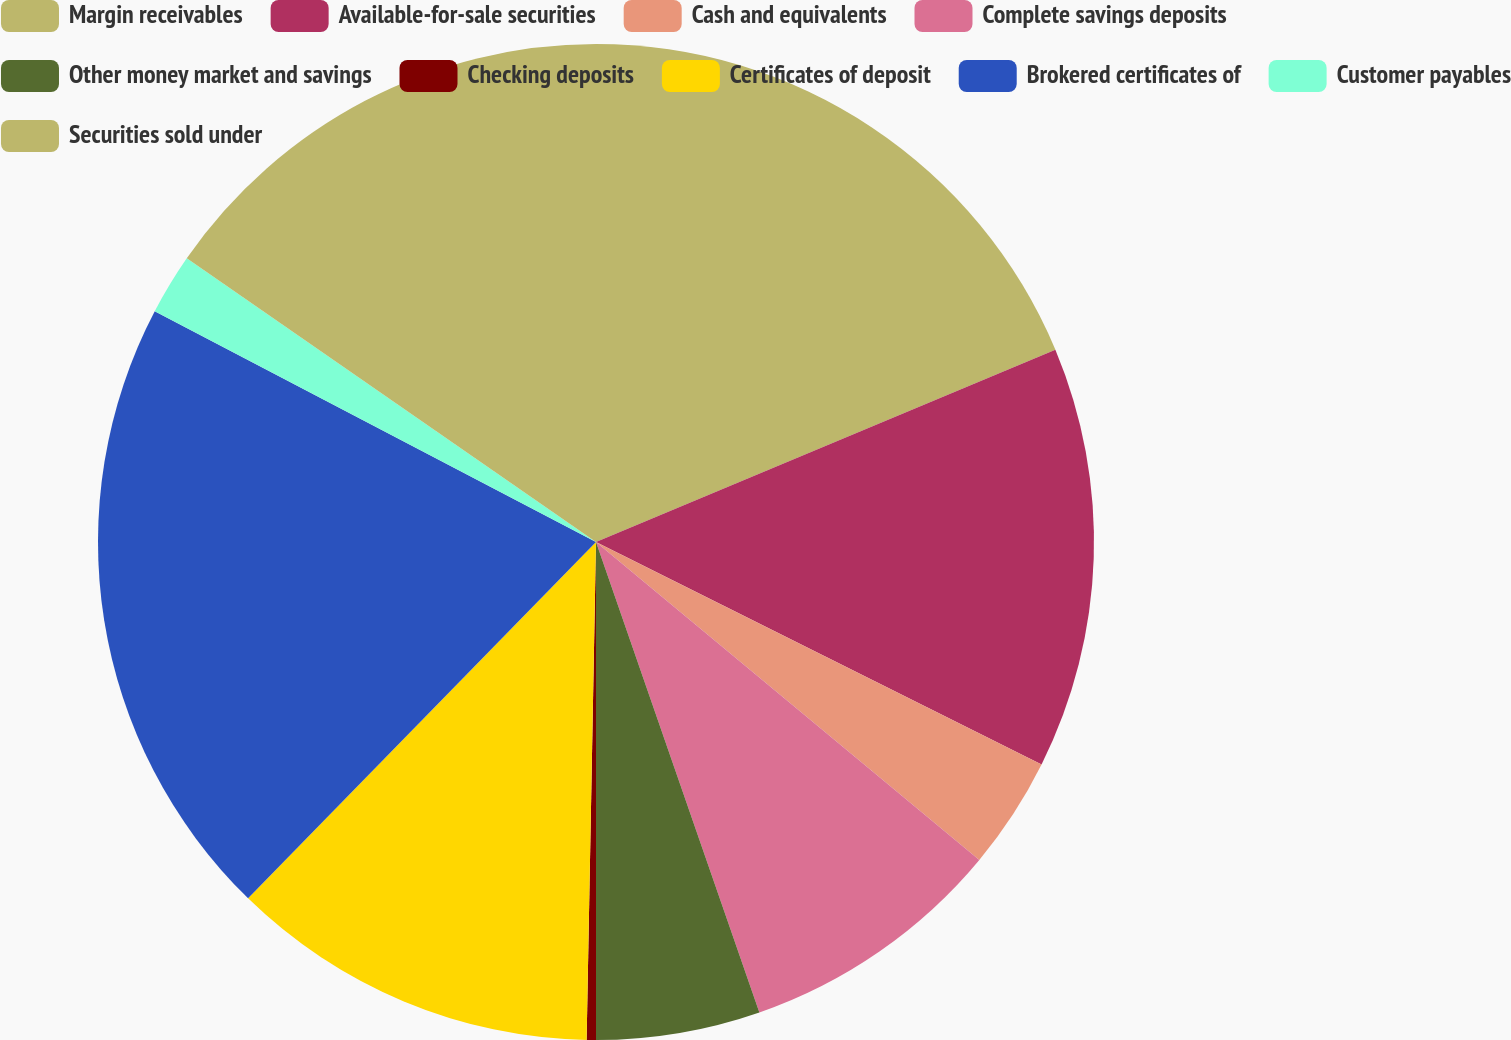Convert chart. <chart><loc_0><loc_0><loc_500><loc_500><pie_chart><fcel>Margin receivables<fcel>Available-for-sale securities<fcel>Cash and equivalents<fcel>Complete savings deposits<fcel>Other money market and savings<fcel>Checking deposits<fcel>Certificates of deposit<fcel>Brokered certificates of<fcel>Customer payables<fcel>Securities sold under<nl><fcel>18.69%<fcel>13.68%<fcel>3.65%<fcel>8.66%<fcel>5.32%<fcel>0.3%<fcel>12.01%<fcel>20.36%<fcel>1.98%<fcel>15.35%<nl></chart> 